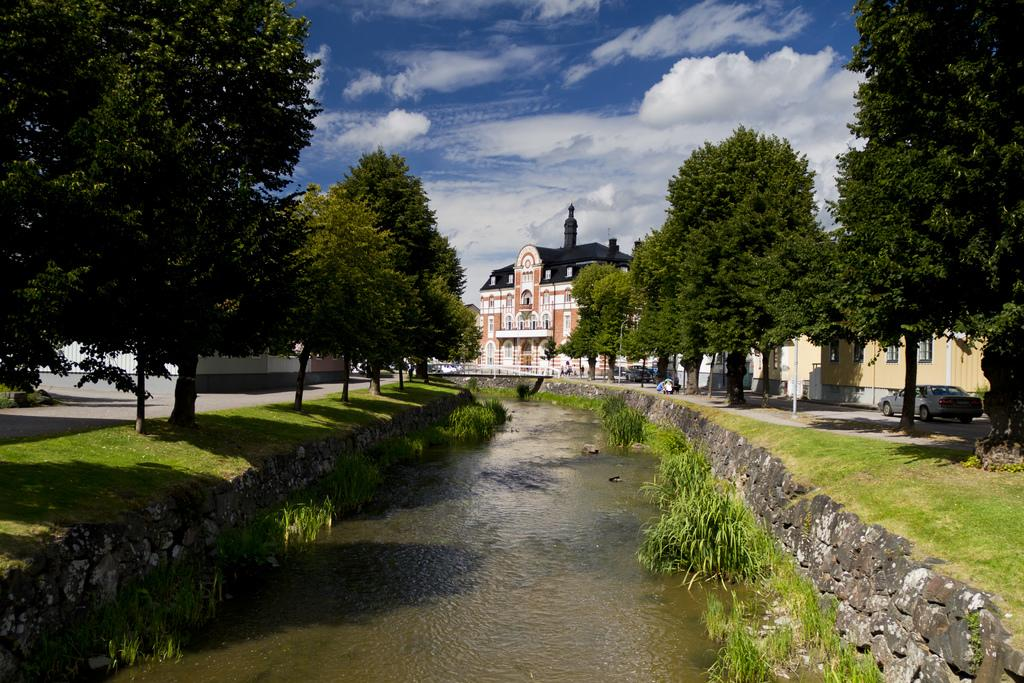What type of water feature is visible in the image? There is a canal in the image. What can be seen on either side of the canal? There are trees and roads on either side of the canal. What type of vehicles can be seen on the roads? Cars are present on the roads. What is visible in the background of the image? There is a house and a blue sky in the background of the image. How many sisters are playing with the pigs in the image? There are no sisters or pigs present in the image. 